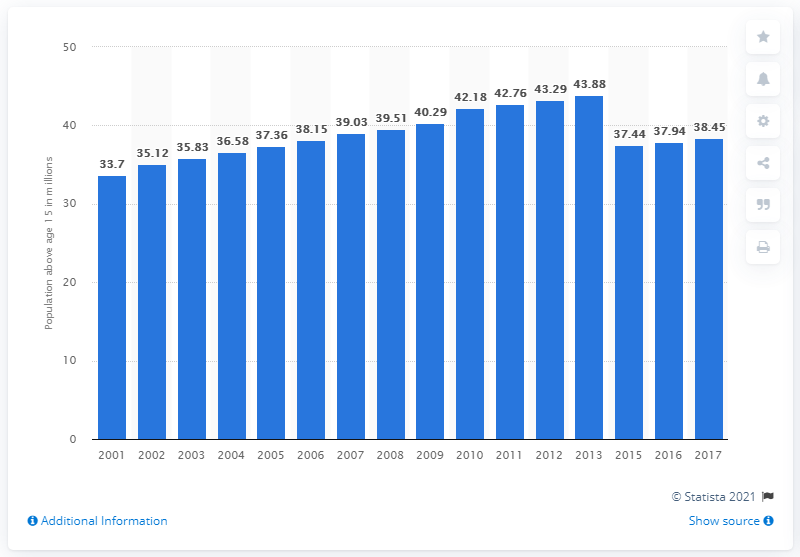Give some essential details in this illustration. In 2017, the working-age population in Burma was 38.45. 